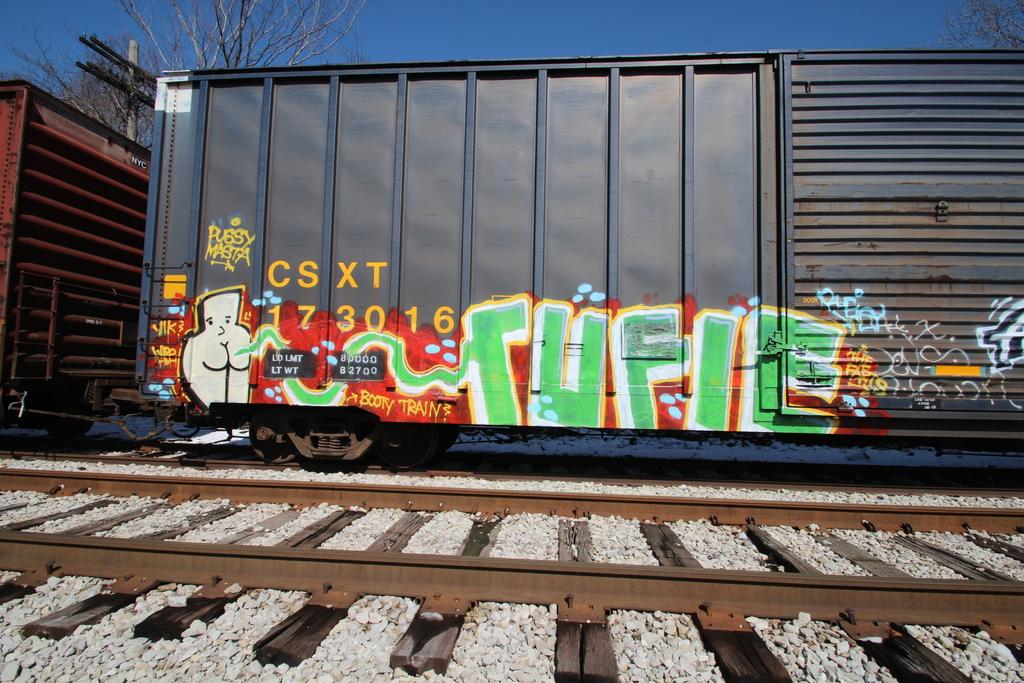<image>
Present a compact description of the photo's key features. Train that says CSXT 173016 with some graffiti on it. 